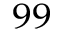<formula> <loc_0><loc_0><loc_500><loc_500>_ { 9 9 }</formula> 